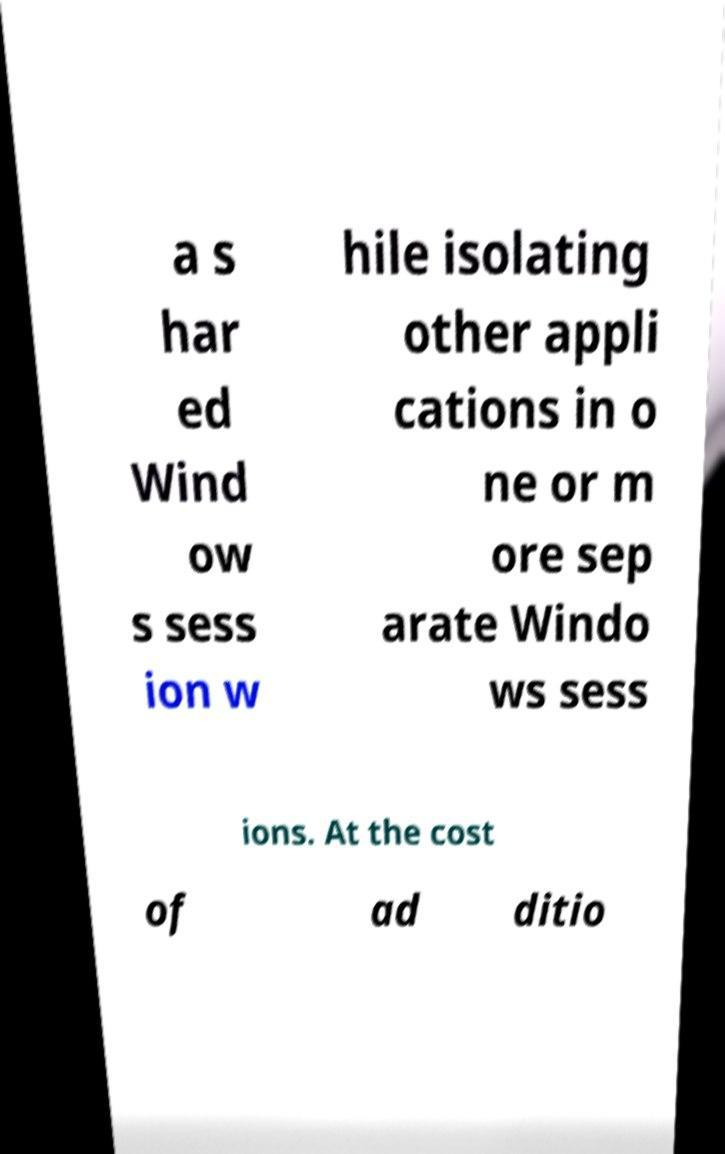Could you extract and type out the text from this image? a s har ed Wind ow s sess ion w hile isolating other appli cations in o ne or m ore sep arate Windo ws sess ions. At the cost of ad ditio 